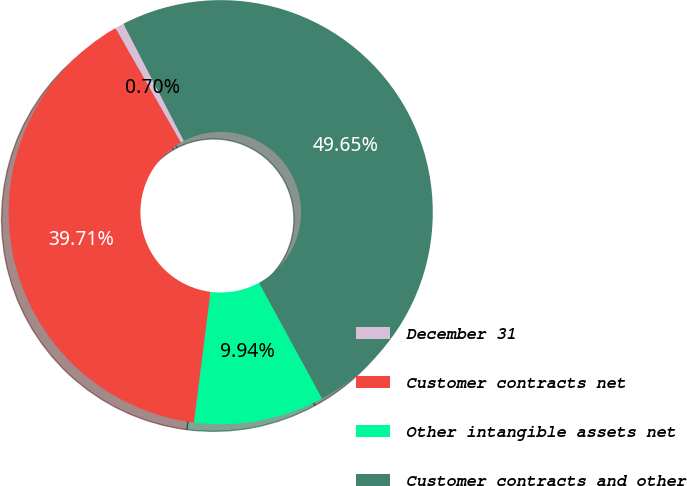Convert chart to OTSL. <chart><loc_0><loc_0><loc_500><loc_500><pie_chart><fcel>December 31<fcel>Customer contracts net<fcel>Other intangible assets net<fcel>Customer contracts and other<nl><fcel>0.7%<fcel>39.71%<fcel>9.94%<fcel>49.65%<nl></chart> 